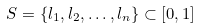Convert formula to latex. <formula><loc_0><loc_0><loc_500><loc_500>S = \left \{ l _ { 1 } , l _ { 2 } , \dots , l _ { n } \right \} \subset \left [ 0 , 1 \right ]</formula> 